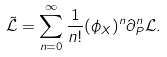<formula> <loc_0><loc_0><loc_500><loc_500>\tilde { \mathcal { L } } = \sum _ { n = 0 } ^ { \infty } \frac { 1 } { n ! } ( \phi _ { X } ) ^ { n } \partial _ { P } ^ { n } { \mathcal { L } } .</formula> 